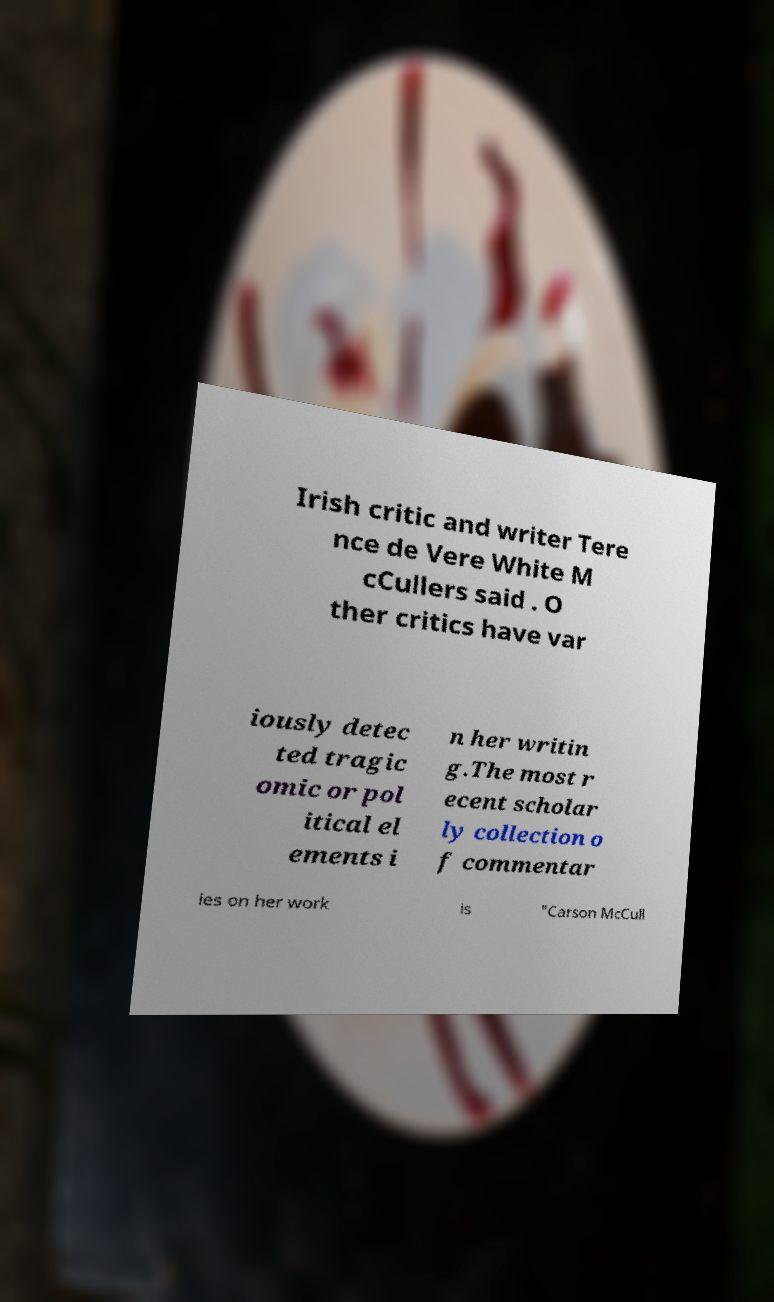Please read and relay the text visible in this image. What does it say? Irish critic and writer Tere nce de Vere White M cCullers said . O ther critics have var iously detec ted tragic omic or pol itical el ements i n her writin g.The most r ecent scholar ly collection o f commentar ies on her work is "Carson McCull 